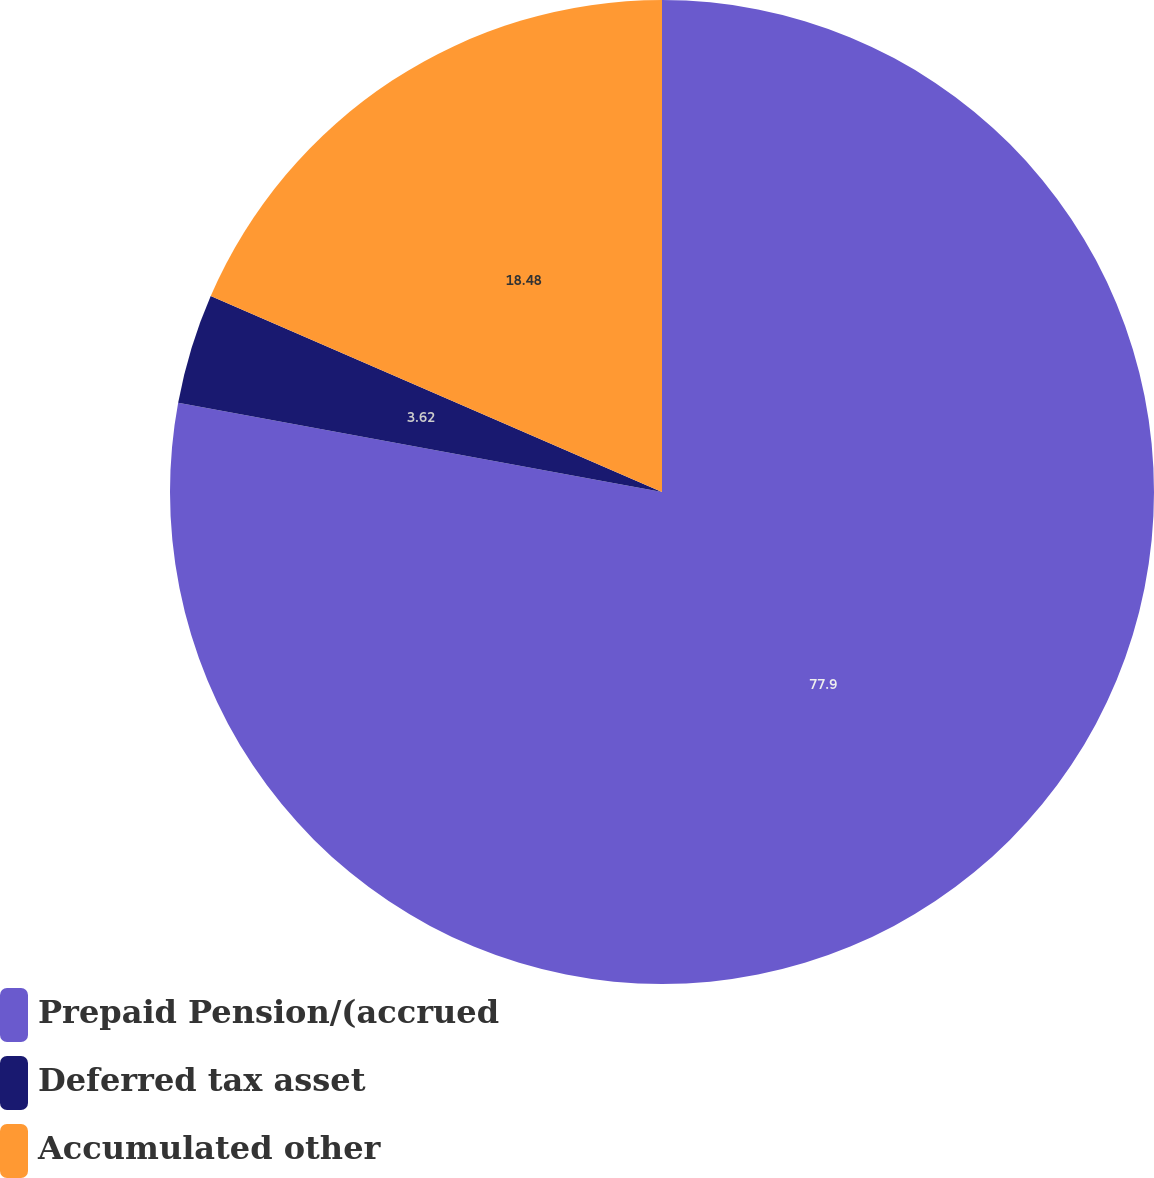<chart> <loc_0><loc_0><loc_500><loc_500><pie_chart><fcel>Prepaid Pension/(accrued<fcel>Deferred tax asset<fcel>Accumulated other<nl><fcel>77.91%<fcel>3.62%<fcel>18.48%<nl></chart> 